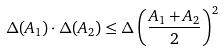<formula> <loc_0><loc_0><loc_500><loc_500>& \Delta ( A _ { 1 } ) \cdot \Delta ( A _ { 2 } ) \leq \Delta \left ( \frac { A _ { 1 } + A _ { 2 } } { 2 } \right ) ^ { 2 }</formula> 